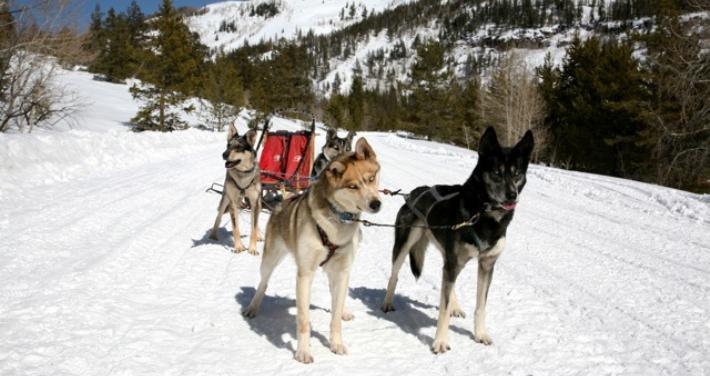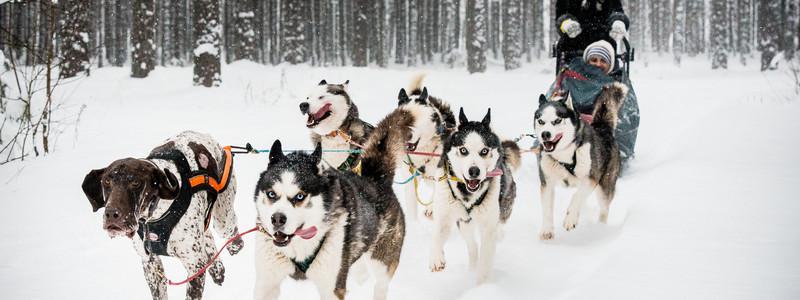The first image is the image on the left, the second image is the image on the right. Analyze the images presented: Is the assertion "The dog sled team on the right heads diagonally to the left, and the dog team on the left heads toward the camera." valid? Answer yes or no. No. The first image is the image on the left, the second image is the image on the right. For the images displayed, is the sentence "The dogs in the left image are standing still, and the dogs in the right image are running." factually correct? Answer yes or no. Yes. 